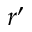Convert formula to latex. <formula><loc_0><loc_0><loc_500><loc_500>r ^ { \prime }</formula> 